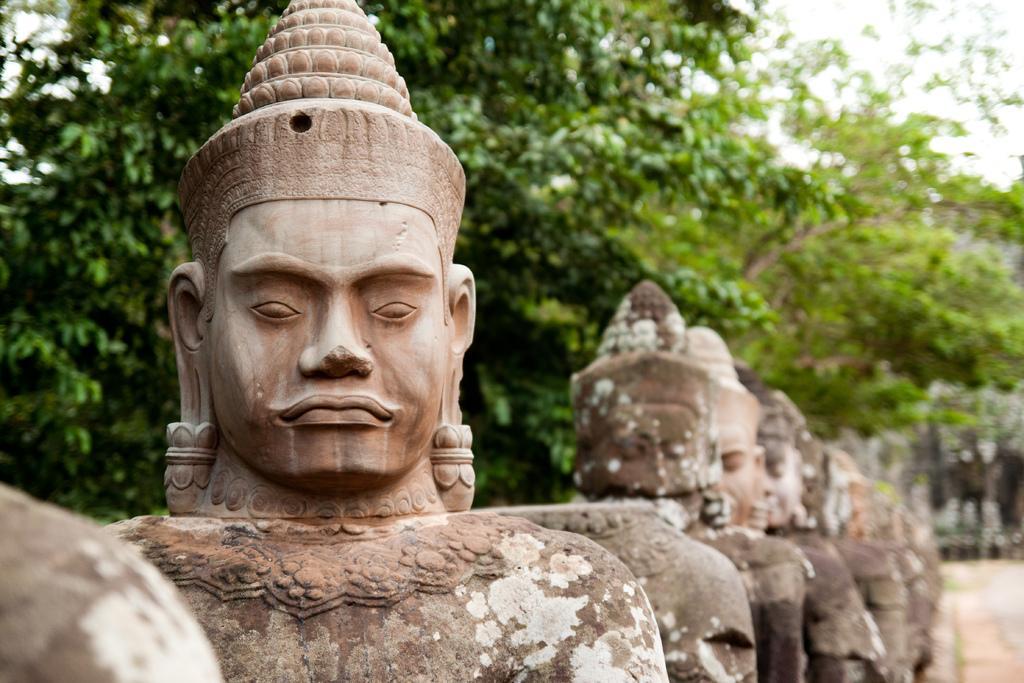Could you give a brief overview of what you see in this image? This image consists of sculptures. In the background, there are trees. At the top, there is sky. On the bottom right, we can see the ground. 